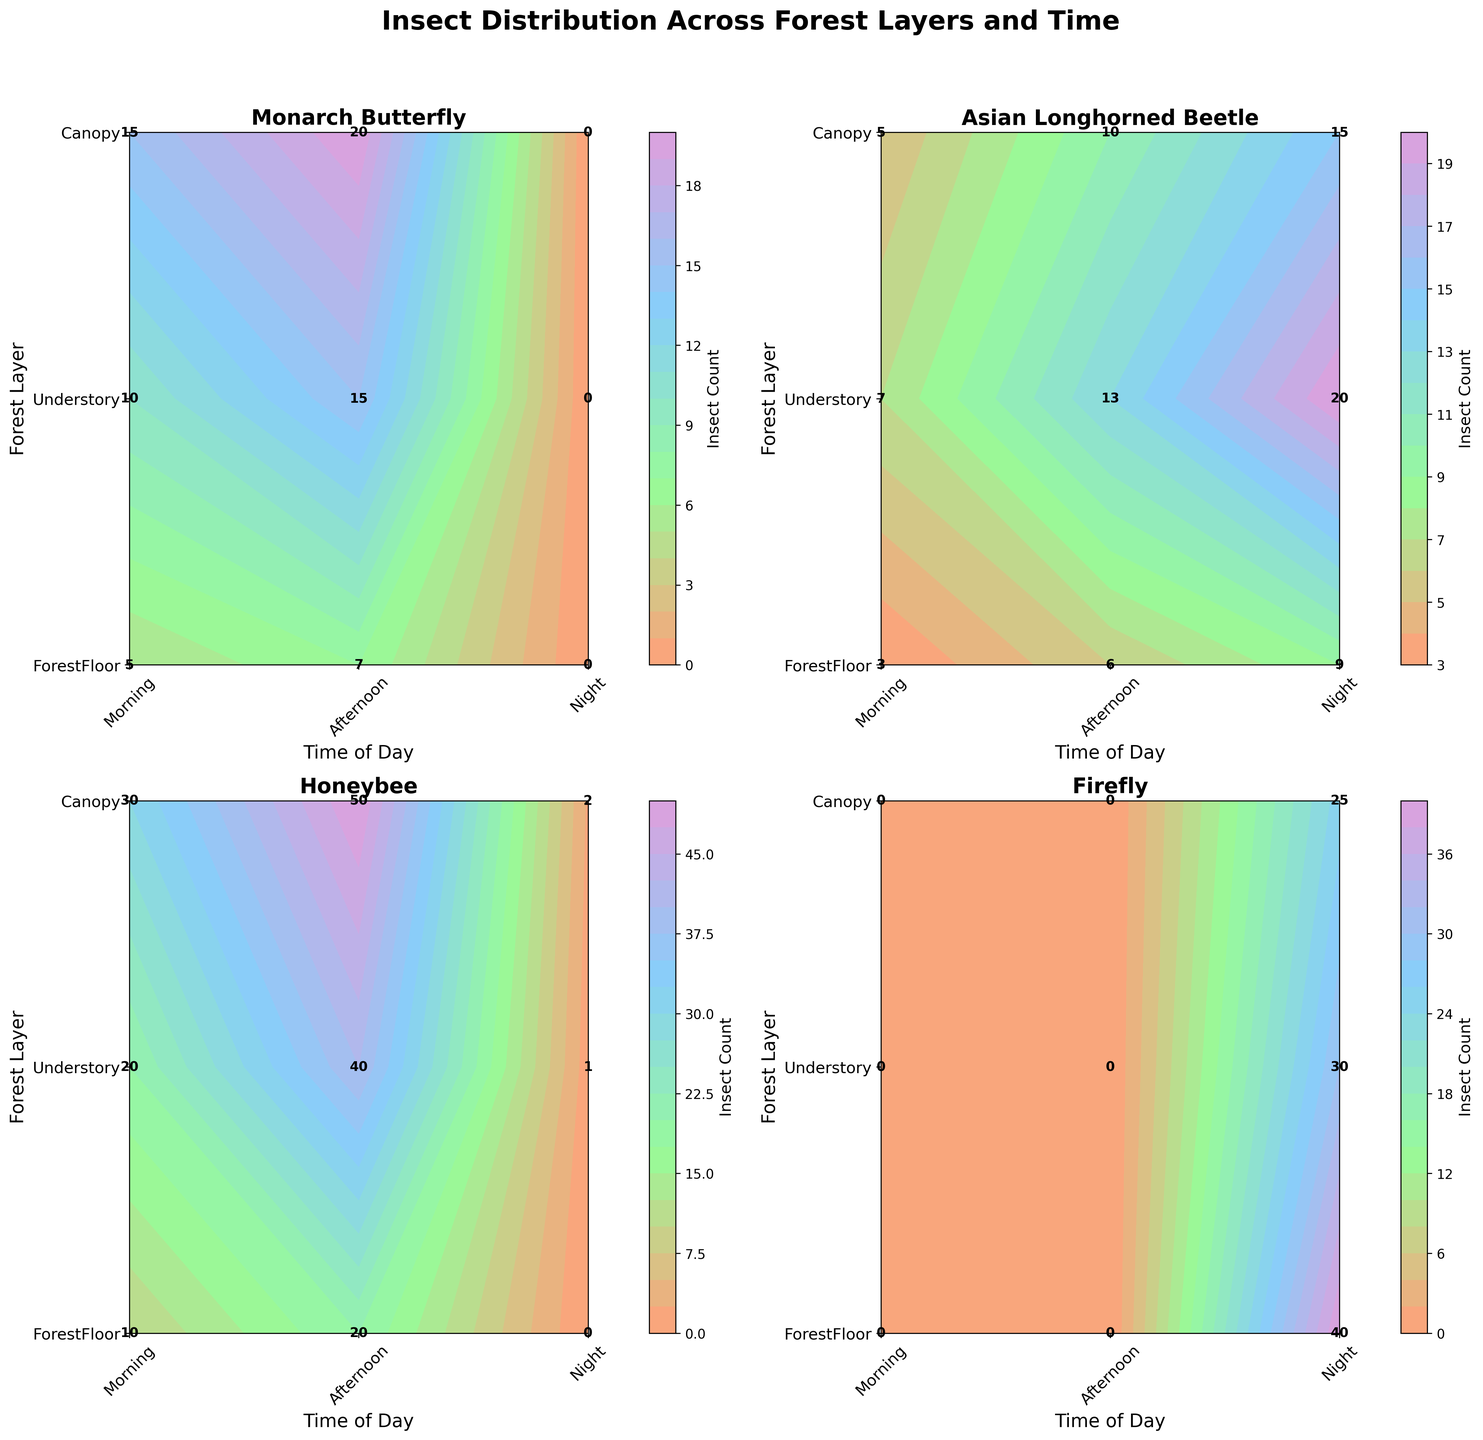Which forest layer has the highest count of Honeybees in the Afternoon? We look for the count of Honeybees in the Afternoon across ForestFloor, Understory, and Canopy. The counts are 20, 40, and 50 respectively. Canopy has the highest count.
Answer: Canopy What is the total count of Monarch Butterflies across all forest layers in the Morning? We sum the counts of Monarch Butterflies in the Morning across the ForestFloor, Understory, and Canopy. The counts are 5, 10, and 15, respectively. The total count is 5 + 10 + 15 = 30.
Answer: 30 How does the count of Fireflies at Night on the Forest Floor compare to the Canopy? We compare the count of Fireflies at Night on the ForestFloor and Canopy. The counts are 40 and 25 respectively. The count of Fireflies is higher on the ForestFloor.
Answer: ForestFloor Which insect has the lowest count in the Canopy during the Morning? We compare the Morning counts in the Canopy of all insects: Monarch Butterfly (15), Asian Longhorned Beetle (5), Honeybee (30), Firefly (0). Firefly has the lowest count.
Answer: Firefly Is the count of Asian Longhorned Beetles higher or lower on the Forest Floor during the Night compared to the Understory during the Night? We compare the Night counts of Asian Longhorned Beetles on the ForestFloor (9) and Understory (20). It is lower on the ForestFloor.
Answer: Lower What is the average count of Honeybees in the Understory across all times of day? We sum the counts of Honeybees in the Understory at Morning (20), Afternoon (40), and Night (1), giving a total of 61. The average is 61/3 ≈ 20.33.
Answer: 20.33 Among the given forest layers, at which time of the day is there no count of Monarch Butterflies? We look at the counts of Monarch Butterflies at Night across all layers: Canopy (0), Understory (0), ForestFloor (0). There are no Monarch Butterflies at Night.
Answer: Night What is the difference in count of Fireflies at Night between the Understory and Forest Floor? The count of Fireflies at Night in the Understory is 30, and on the ForestFloor is 40. The difference is 40 - 30 = 10.
Answer: 10 In which time of day and forest layer combination is the count of Asian Longhorned Beetles the highest? We look at all the combinations of layers and times for Asian Longhorned Beetles: Canopy (Morning-5, Afternoon-10, Night-15), Understory (Morning-7, Afternoon-13, Night-20), ForestFloor (Morning-3, Afternoon-6, Night-9). The highest count is 20 at Night in the Understory.
Answer: Night, Understory 